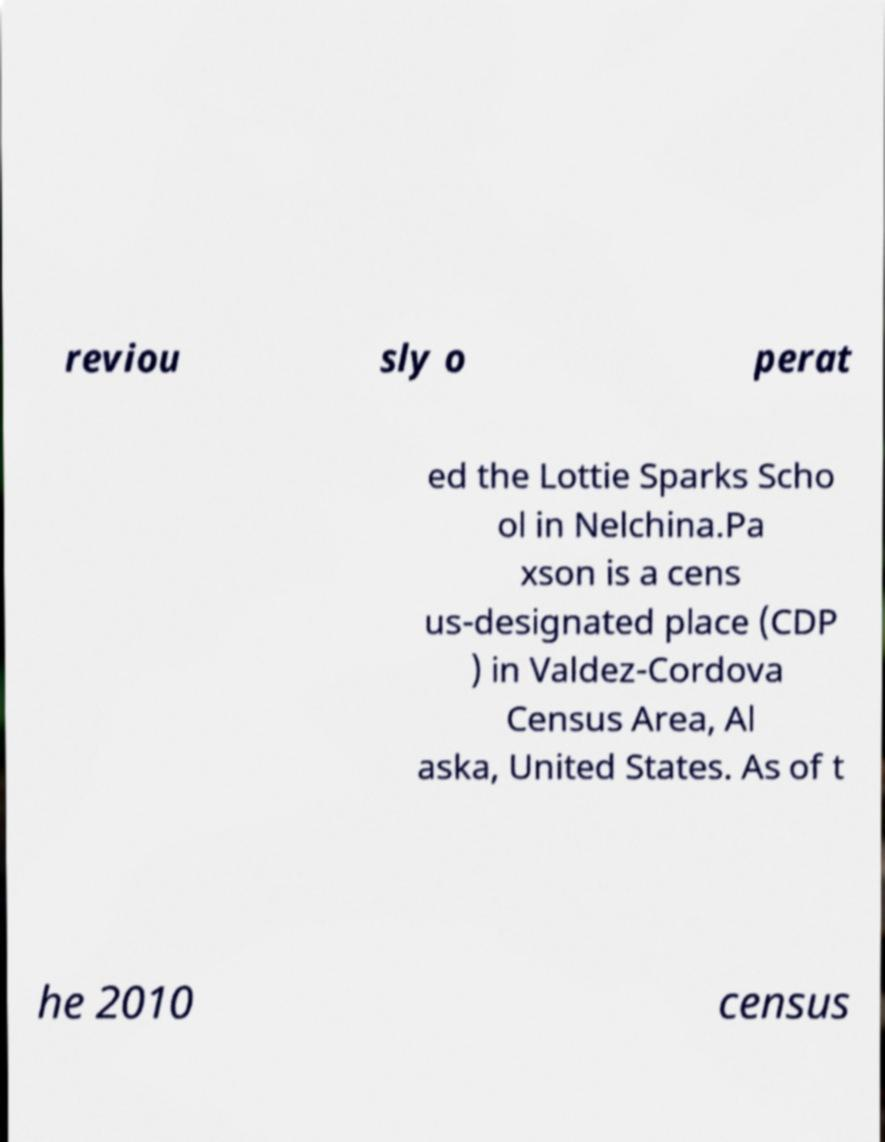Can you read and provide the text displayed in the image?This photo seems to have some interesting text. Can you extract and type it out for me? reviou sly o perat ed the Lottie Sparks Scho ol in Nelchina.Pa xson is a cens us-designated place (CDP ) in Valdez-Cordova Census Area, Al aska, United States. As of t he 2010 census 